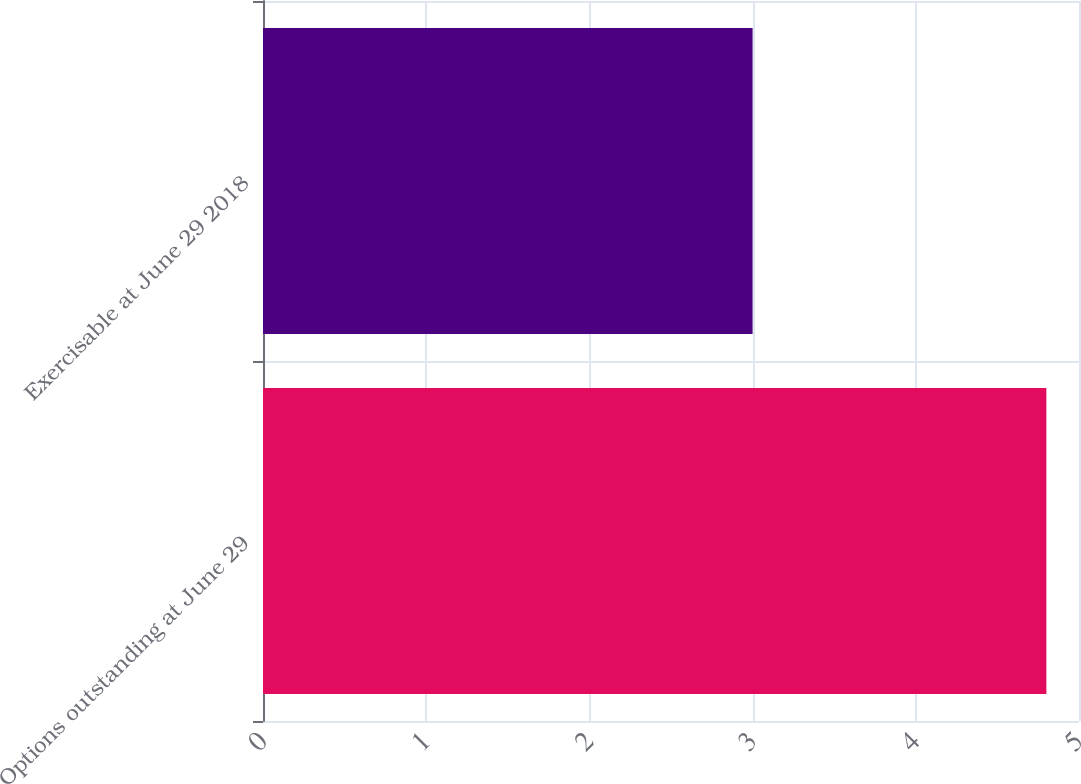<chart> <loc_0><loc_0><loc_500><loc_500><bar_chart><fcel>Options outstanding at June 29<fcel>Exercisable at June 29 2018<nl><fcel>4.8<fcel>3<nl></chart> 